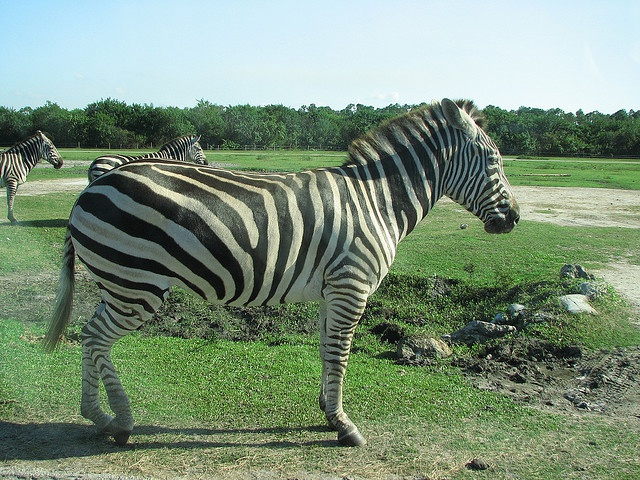Describe the objects in this image and their specific colors. I can see zebra in lightblue, gray, black, and darkgray tones, zebra in lightblue, black, gray, darkgray, and beige tones, and zebra in lightblue, black, gray, beige, and darkgray tones in this image. 